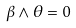<formula> <loc_0><loc_0><loc_500><loc_500>\beta \wedge \theta = 0</formula> 